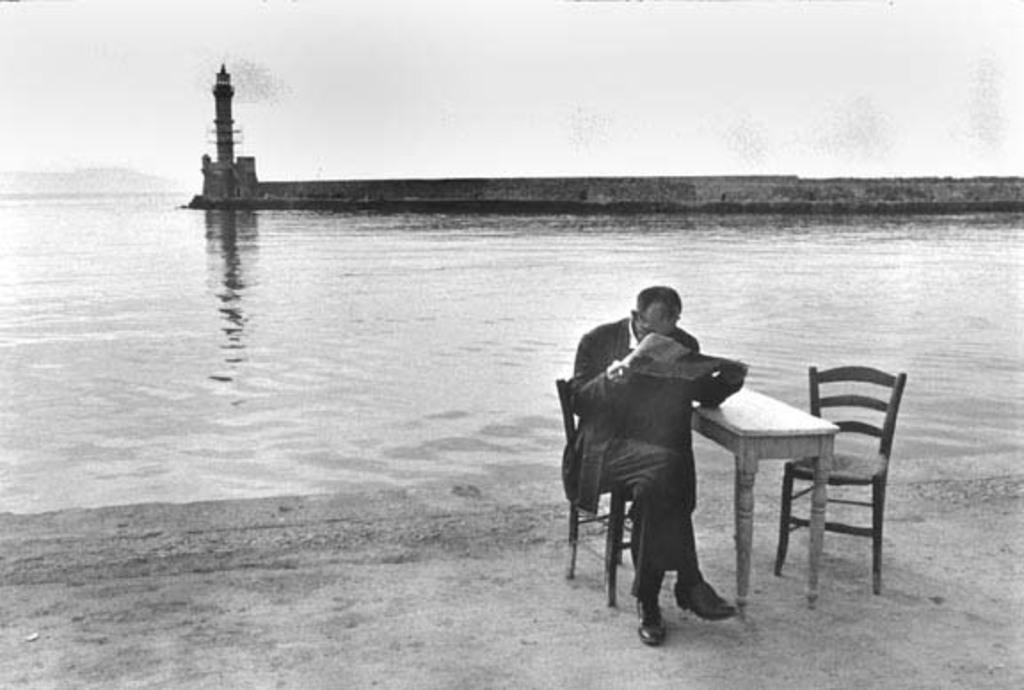Describe this image in one or two sentences. In this picture I can see there are two chairs and there is a table, the man is sitting on the chair and reading the news paper and the man is sitting on the beach side. There is a lighthouse in the backdrop and this is a black and white picture. 